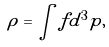Convert formula to latex. <formula><loc_0><loc_0><loc_500><loc_500>\rho = \int f d ^ { 3 } { p } ,</formula> 